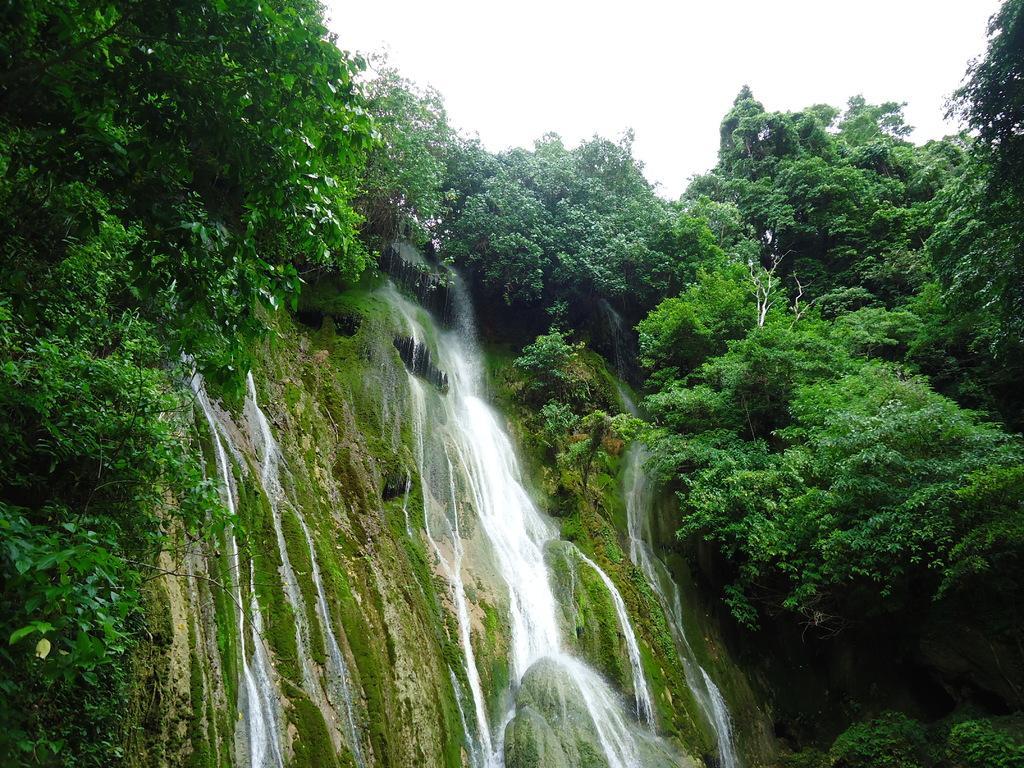Can you describe this image briefly? In the background there is a sky at the top of the picture. Here we can see trees. This is a waterfall. There are the mountains. There is a formation of algae on the mountains. 